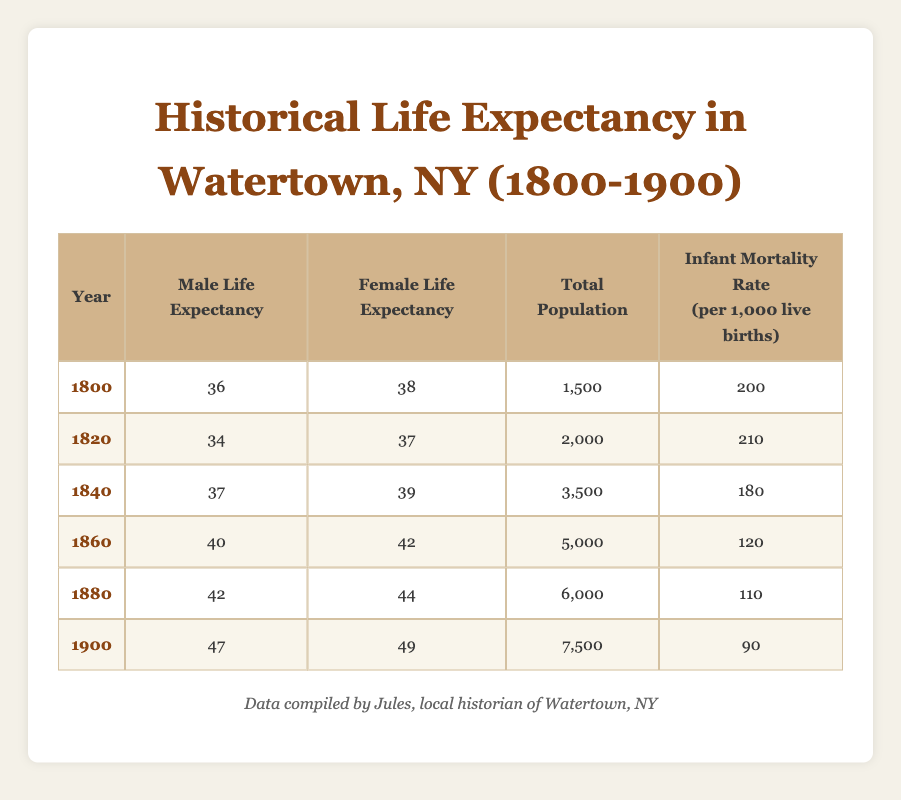What was the male life expectancy in 1860? According to the table, the male life expectancy for the year 1860 is explicitly listed as 40.
Answer: 40 What was the total population of Watertown in 1820? The table shows that the total population for the year 1820 is 2,000.
Answer: 2,000 Is the infant mortality rate in 1900 lower than that in 1800? The table states that the infant mortality rate for 1900 is 90, while for 1800 it is 200. Since 90 is less than 200, the answer is yes.
Answer: Yes What is the difference in female life expectancy between the years 1840 and 1880? The female life expectancy in 1840 is 39, and in 1880, it is 44. The difference is calculated as 44 - 39 = 5.
Answer: 5 What was the average male life expectancy from 1800 to 1900? The male life expectancies for the years 1800, 1820, 1840, 1860, 1880, and 1900 are 36, 34, 37, 40, 42, and 47. To find the average, sum these values (36 + 34 + 37 + 40 + 42 + 47 = 236) and divide by the number of data points (6). Therefore, 236/6 = 39.33.
Answer: 39.33 In which year did the male life expectancy first exceed 40 years? By examining the table, the male life expectancy exceeds 40 starting in 1860, where it is 40. Therefore, 1860 is the first year where it meets or exceeds this threshold.
Answer: 1860 Was the total population of Watertown greater in 1880 compared to 1860? The population figures indicate that in 1880, the total population is 6,000, while in 1860 it is 5,000. Since 6,000 is greater than 5,000, the answer is yes.
Answer: Yes What was the trend in female life expectancy from 1800 to 1900? Analyzing the female life expectancy across the years, it shows an increase from 38 in 1800, to 37 in 1820, 39 in 1840, 42 in 1860, 44 in 1880, and 49 in 1900. This indicates a consistent upward trend over the years.
Answer: Increasing How much did the total population increase from 1840 to 1900? The total population in 1840 was 3,500 and in 1900 it was 7,500. The increase can be calculated as 7,500 - 3,500 = 4,000.
Answer: 4,000 